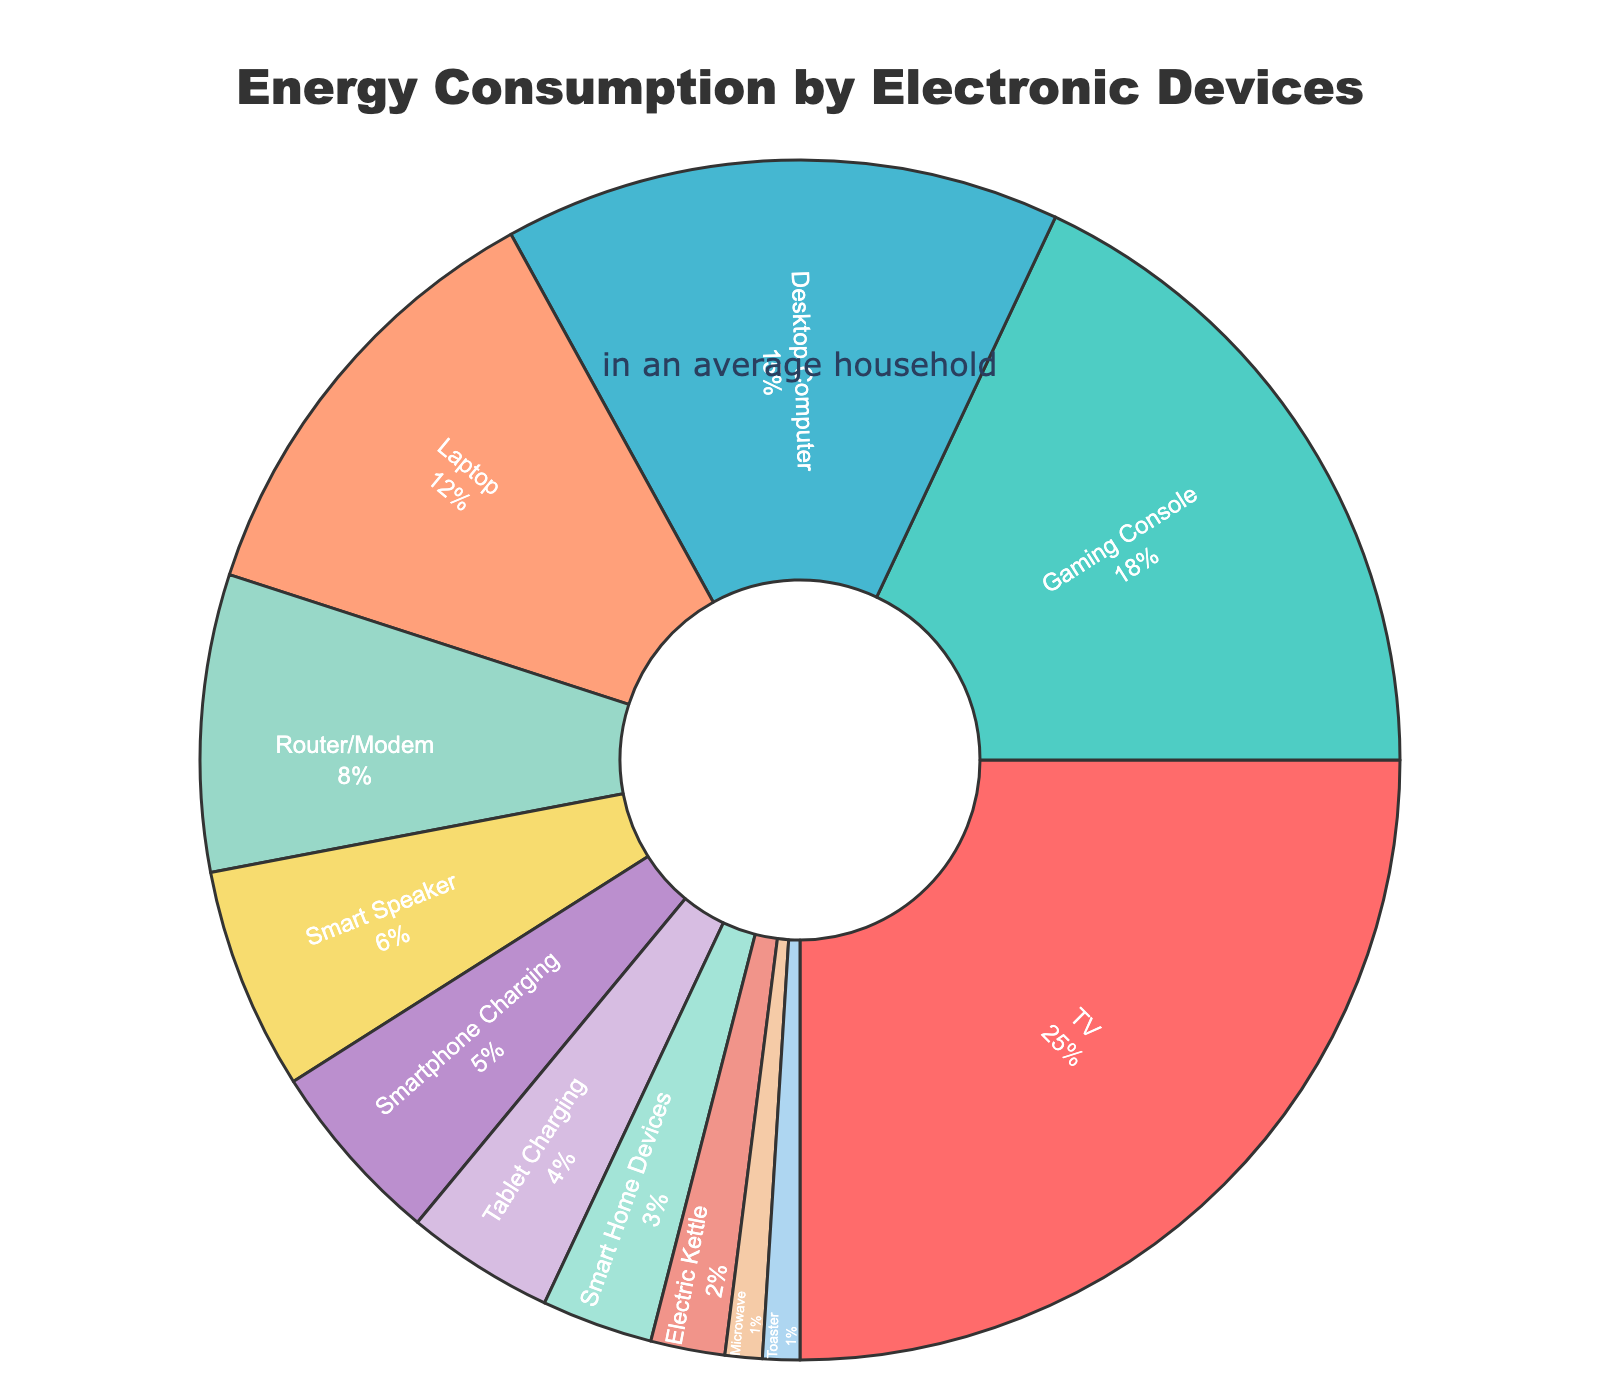Which device consumes the most energy? From the pie chart, the device that consumes the most energy can be identified as the segment with the largest percentage. The TV occupies the largest section at 25%.
Answer: TV How much more energy does a TV consume compared to a gaming console? The energy consumption for the TV is 25%, and for the gaming console, it is 18%. The difference can be calculated by subtracting the gaming console's consumption from the TV's consumption (25% - 18% = 7%).
Answer: 7% What is the total energy consumption of TV, gaming console, and desktop computer combined? To find the total energy consumption of these three devices, add their percentages: TV (25%) + Gaming Console (18%) + Desktop Computer (15%) = 58%.
Answer: 58% Which device consumes 6% of the energy? By identifying the segment labeled with 6%, we find that the Smart Speaker is the device consuming 6% of the energy.
Answer: Smart Speaker Compare the energy consumption between the desktop computer and the laptop. Which one consumes more? The pie chart indicates that the desktop computer consumes 15% of the energy whereas the laptop consumes 12%. Thus, the desktop computer consumes more energy.
Answer: Desktop Computer What fraction of the total energy consumption is accounted for by smartphones, tablets, and smart home devices combined? The energy consumption for these devices is as follows: Smartphone Charging (5%), Tablet Charging (4%), and Smart Home Devices (3%). Adding them, we get 5% + 4% + 3% = 12%.
Answer: 12% How much energy do the router/modem and electric kettle consume together? The energy consumption for the router/modem is 8% and for the electric kettle is 2%. Adding them gives 8% + 2% = 10%.
Answer: 10% Is the energy consumption of the router/modem greater than the combined consumption of the microwave and toaster? The router/modem consumes 8%. The microwave and toaster each consume 1%, so combined they consume 2%. Comparing, 8% is greater than 2%.
Answer: Yes Which two devices have the lowest energy consumption, and what is their combined percentage? From the pie chart, the microwave and toaster each consume 1%. Their combined energy consumption is 1% + 1% = 2%.
Answer: Microwave and Toaster, 2% What combined percentage of energy is consumed by devices labeled green and blue? The gaming console is labeled green and consumes 18%, while the desktop computer is labeled blue and consumes 15%. The combined percentage is 18% + 15% = 33%.
Answer: 33% 